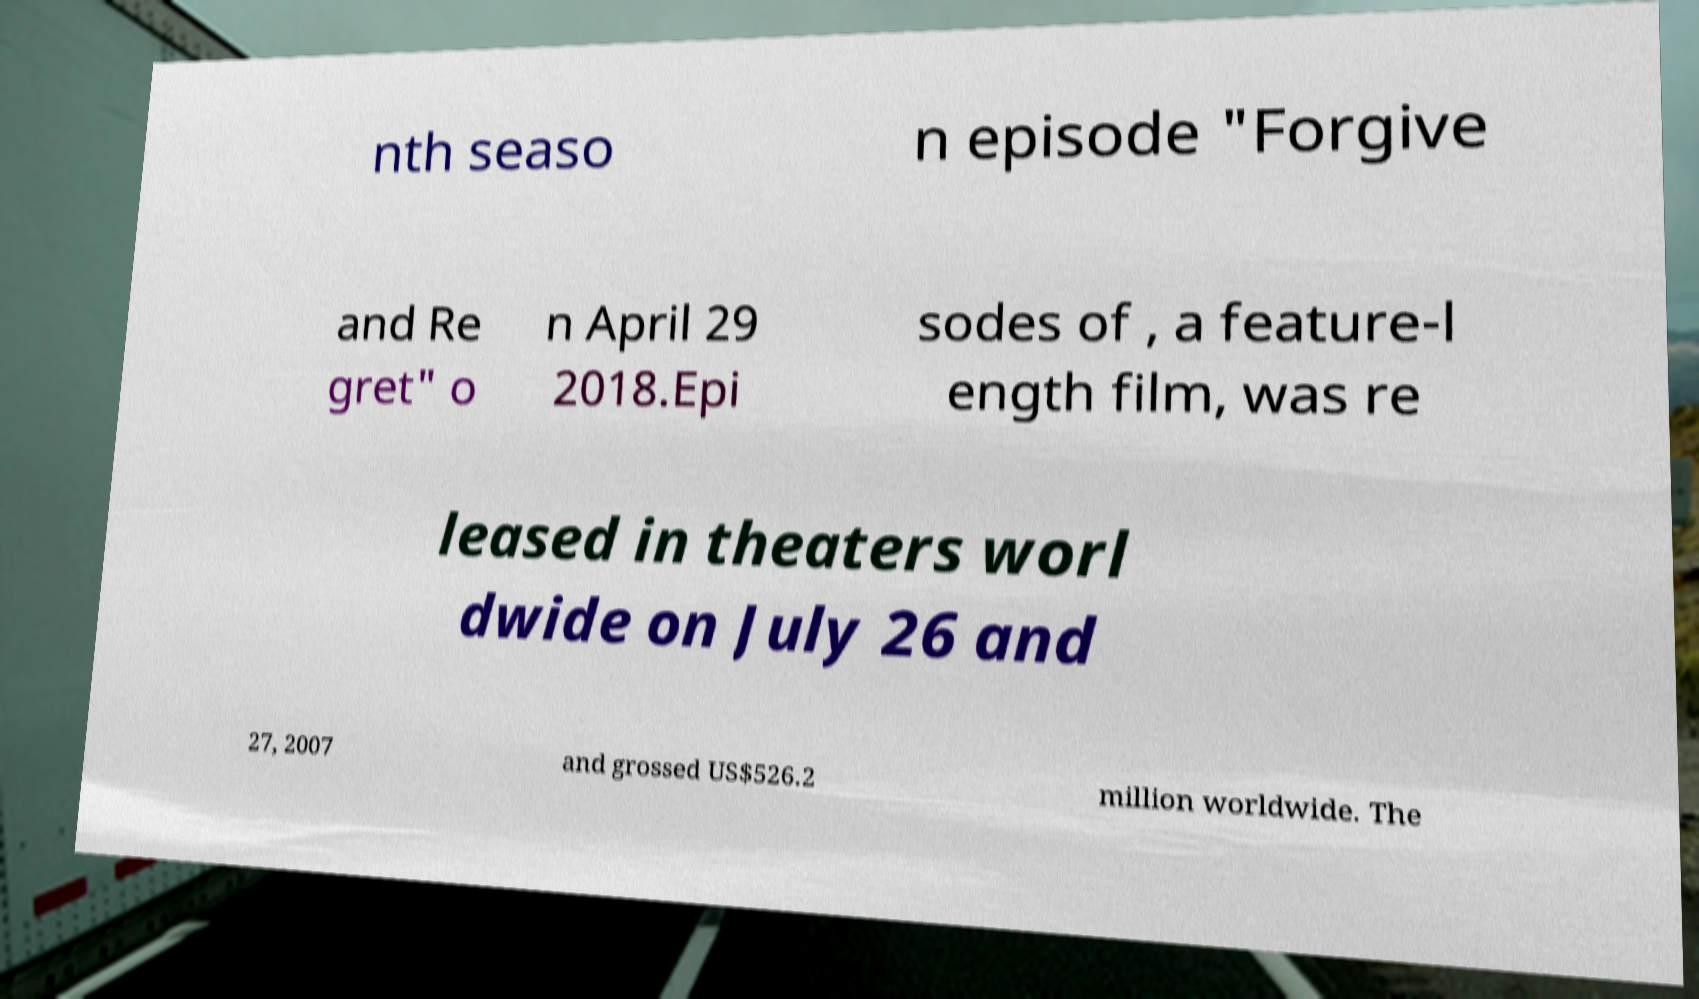I need the written content from this picture converted into text. Can you do that? nth seaso n episode "Forgive and Re gret" o n April 29 2018.Epi sodes of , a feature-l ength film, was re leased in theaters worl dwide on July 26 and 27, 2007 and grossed US$526.2 million worldwide. The 